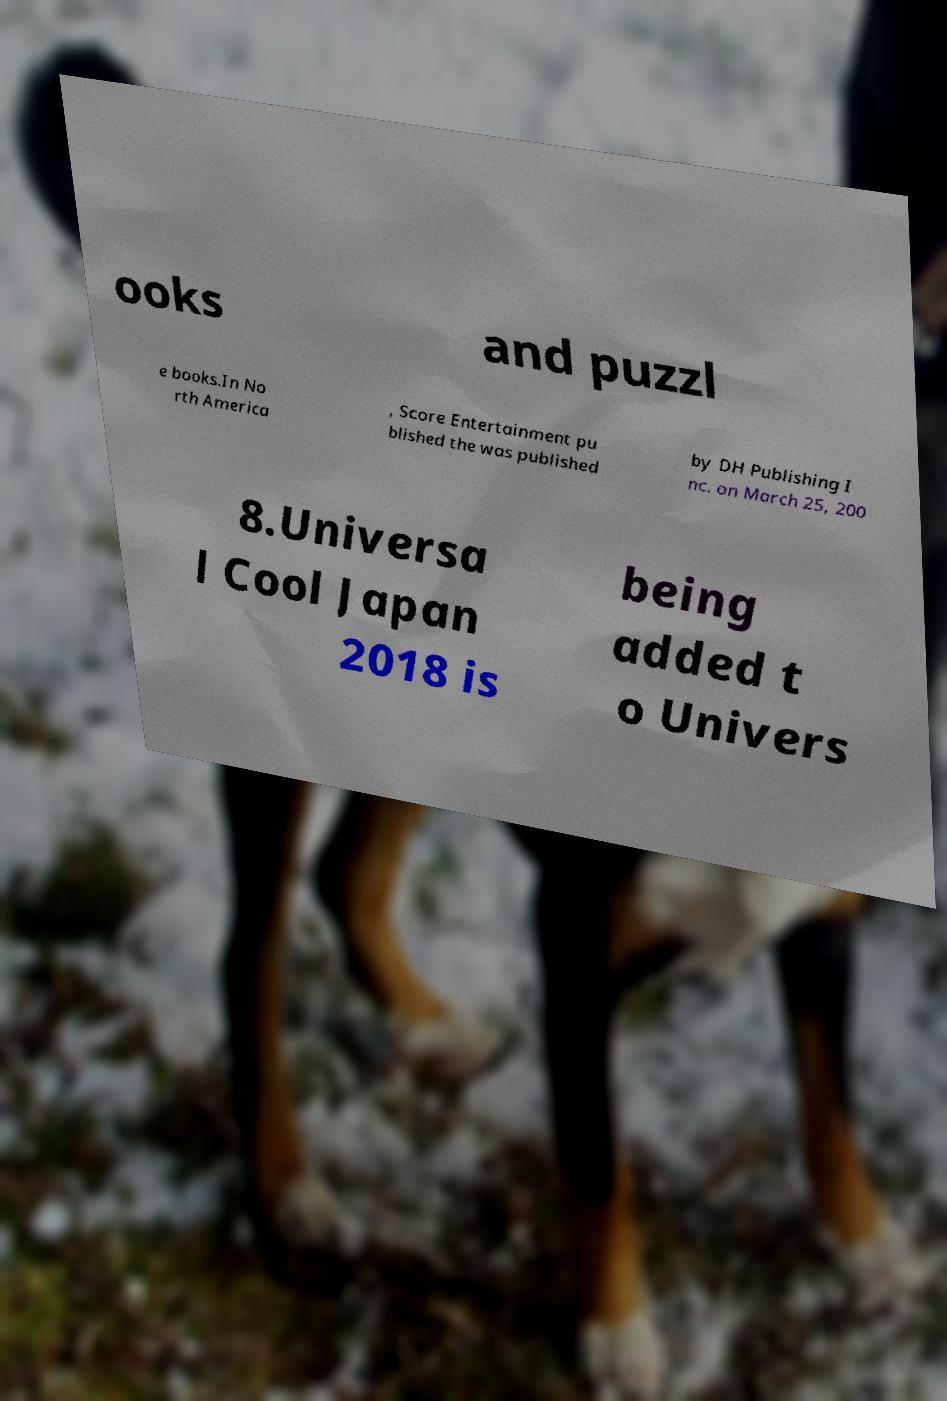Could you extract and type out the text from this image? ooks and puzzl e books.In No rth America , Score Entertainment pu blished the was published by DH Publishing I nc. on March 25, 200 8.Universa l Cool Japan 2018 is being added t o Univers 